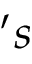Convert formula to latex. <formula><loc_0><loc_0><loc_500><loc_500>^ { \prime } s</formula> 